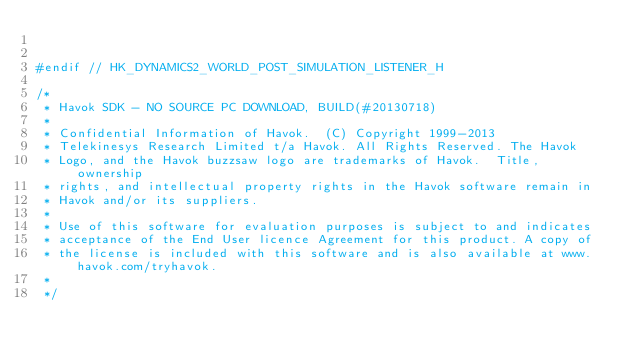Convert code to text. <code><loc_0><loc_0><loc_500><loc_500><_C_>

#endif // HK_DYNAMICS2_WORLD_POST_SIMULATION_LISTENER_H

/*
 * Havok SDK - NO SOURCE PC DOWNLOAD, BUILD(#20130718)
 * 
 * Confidential Information of Havok.  (C) Copyright 1999-2013
 * Telekinesys Research Limited t/a Havok. All Rights Reserved. The Havok
 * Logo, and the Havok buzzsaw logo are trademarks of Havok.  Title, ownership
 * rights, and intellectual property rights in the Havok software remain in
 * Havok and/or its suppliers.
 * 
 * Use of this software for evaluation purposes is subject to and indicates
 * acceptance of the End User licence Agreement for this product. A copy of
 * the license is included with this software and is also available at www.havok.com/tryhavok.
 * 
 */
</code> 